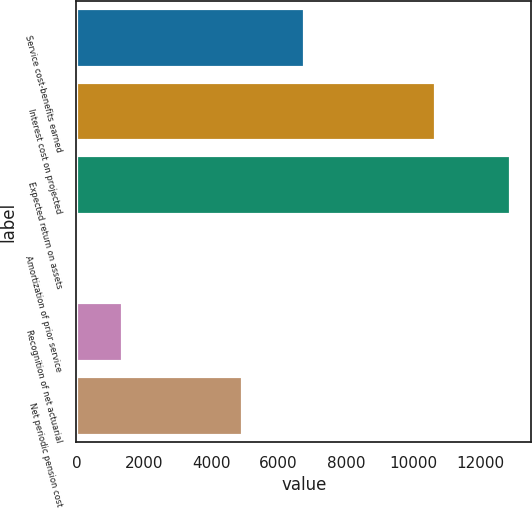<chart> <loc_0><loc_0><loc_500><loc_500><bar_chart><fcel>Service cost-benefits earned<fcel>Interest cost on projected<fcel>Expected return on assets<fcel>Amortization of prior service<fcel>Recognition of net actuarial<fcel>Net periodic pension cost<nl><fcel>6753<fcel>10659<fcel>12868<fcel>60<fcel>1340.8<fcel>4927<nl></chart> 